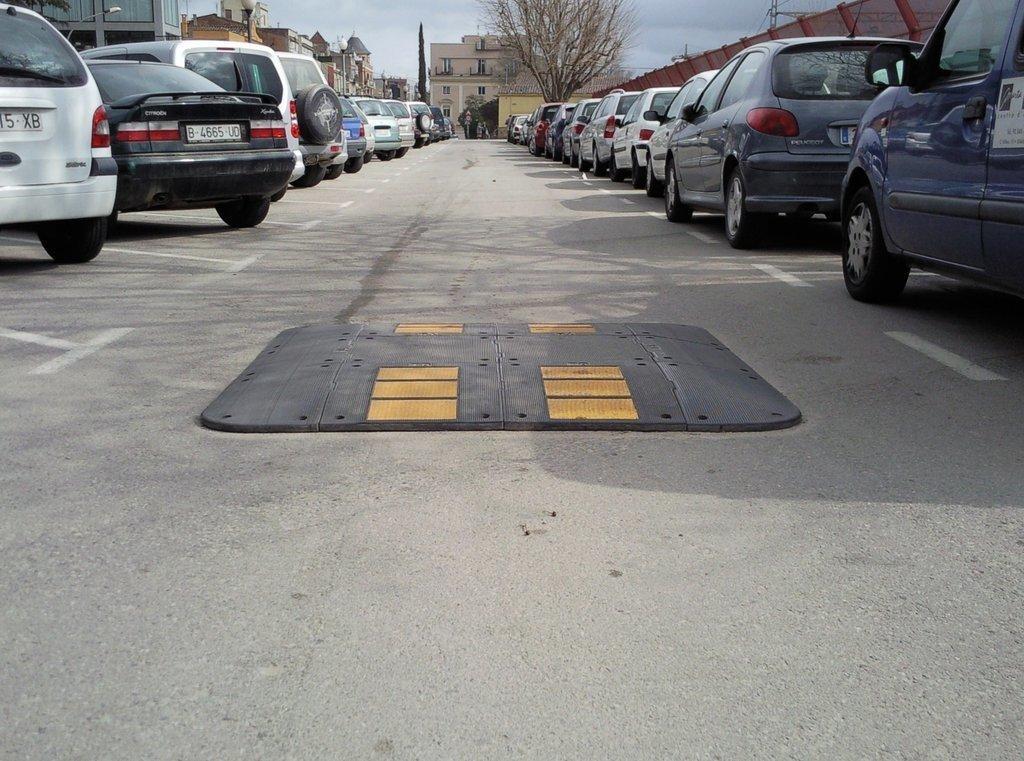Describe this image in one or two sentences. In the picture we can see road, there are some vehicles parked on left and right side of the picture and in the background of the picture there are some houses, trees and clear sky. 